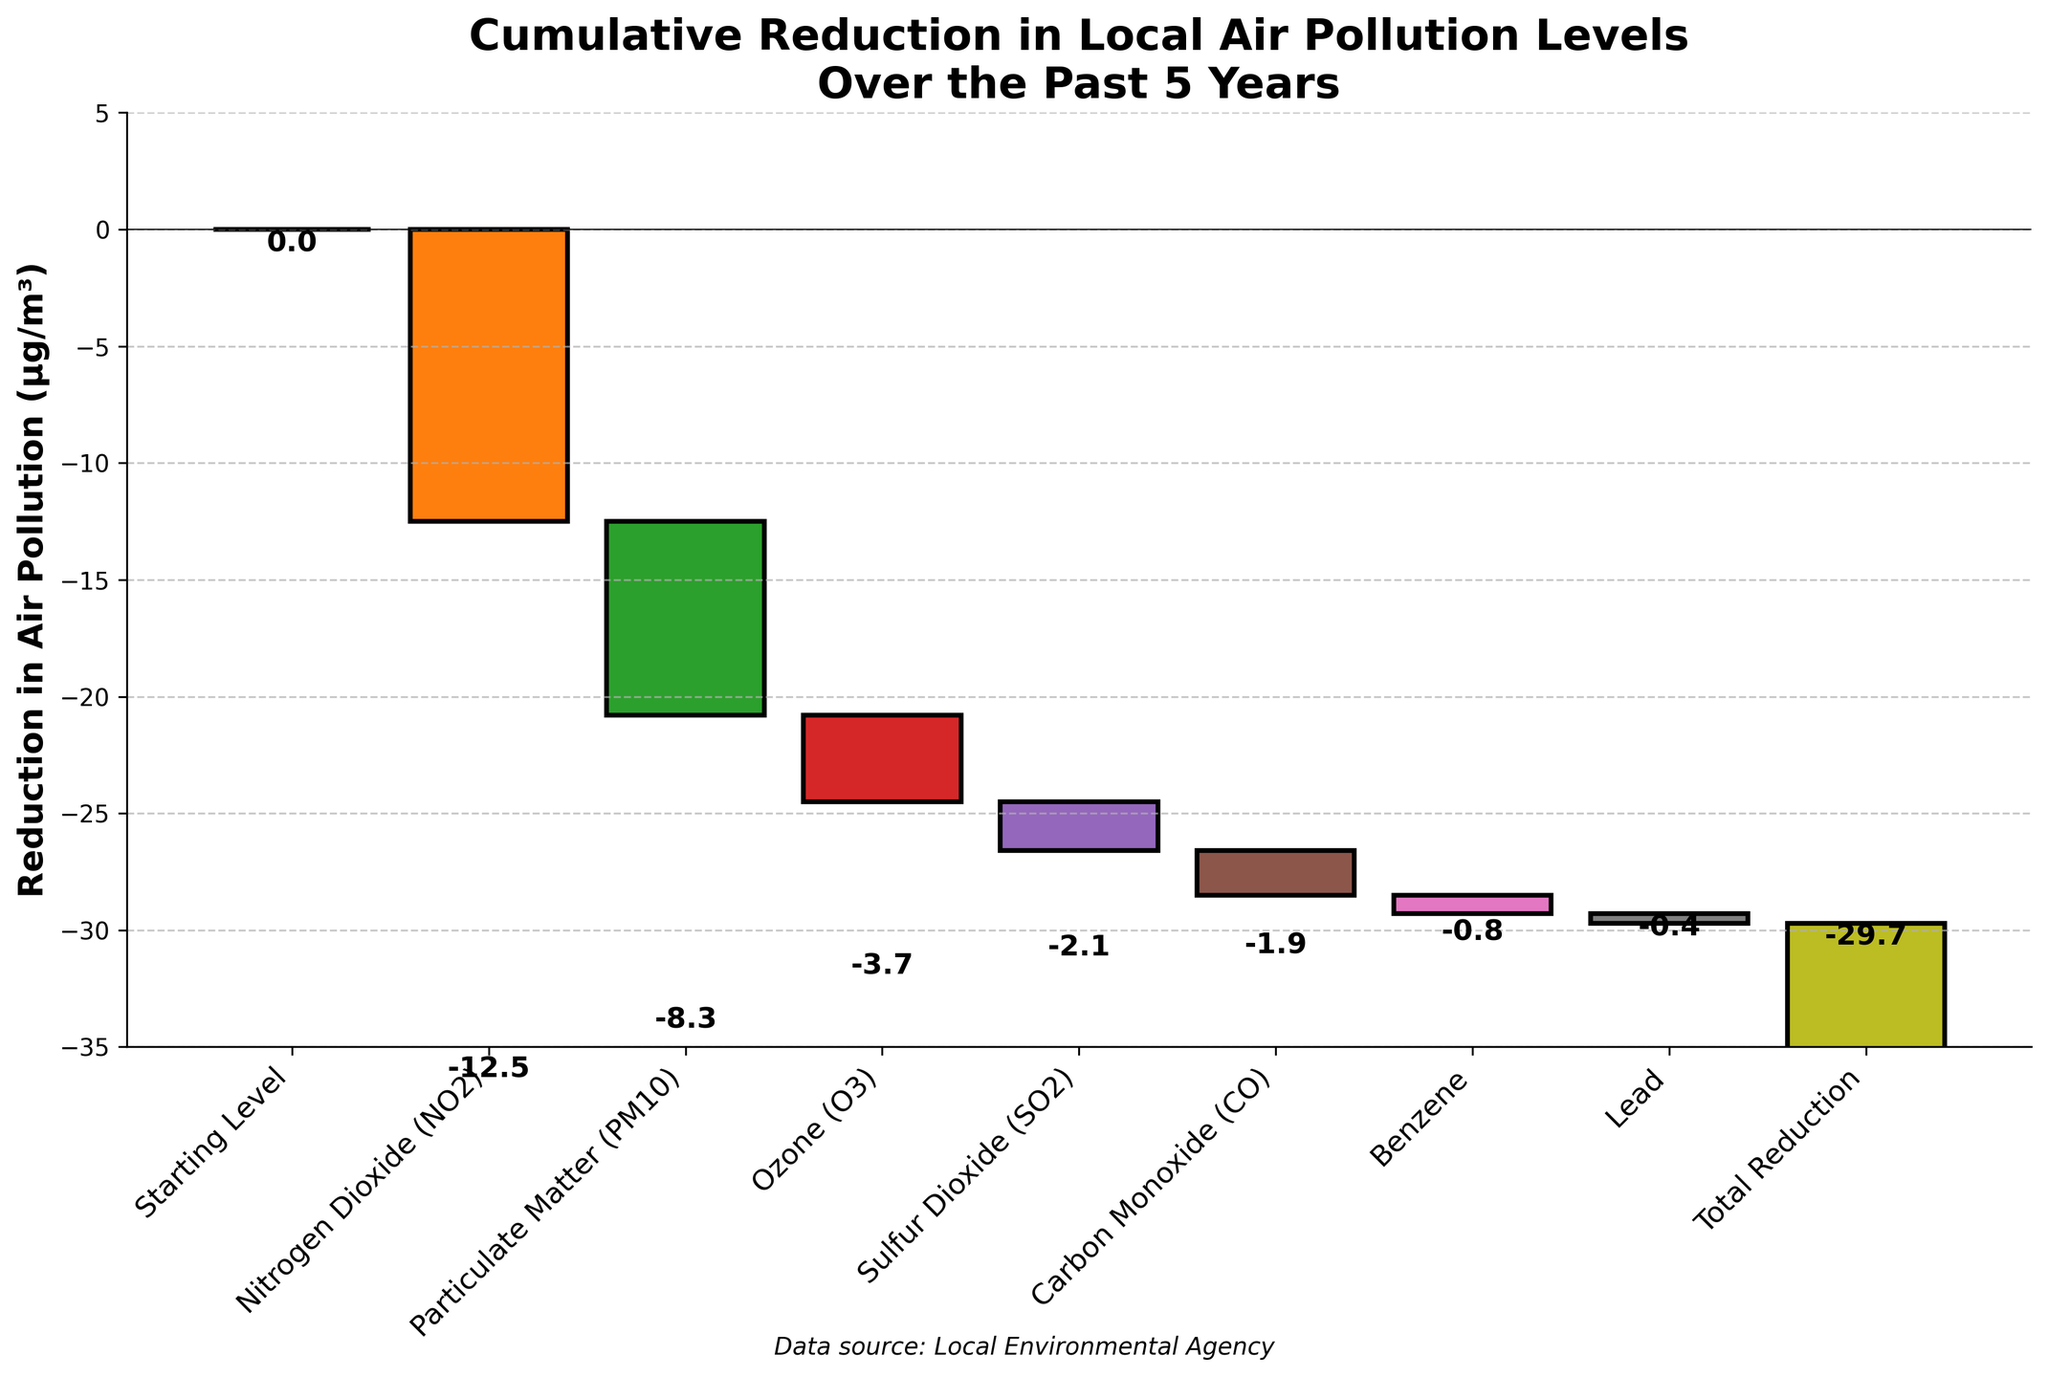What's the total reduction in local air pollution levels over the past 5 years? The chart's title states "Cumulative Reduction in Local Air Pollution Levels Over the Past 5 Years," and the bar labeled "Total Reduction" at the end shows a value of -29.7 µg/m³. So, the total reduction is -29.7 µg/m³.
Answer: -29.7 µg/m³ Which pollutant type had the largest reduction in air pollution? Looking at the bars in the chart, the Nitrogen Dioxide (NO2) bar has the largest negative value, indicating the largest reduction in air pollution levels.
Answer: Nitrogen Dioxide (NO2) Which pollutant shows the smallest reduction in air pollution levels? By comparing the bars, the Lead bar has the smallest negative value of -0.4 µg/m³.
Answer: Lead How much more reduction in air pollution was achieved by Nitrogen Dioxide (NO2) compared to Ozone (O3)? The reduction for NO2 is -12.5 µg/m³, and for O3, it is -3.7 µg/m³. The difference is -12.5 - (-3.7) = -12.5 + 3.7 = -8.8 µg/m³.
Answer: -8.8 µg/m³ What is the combined reduction for Particulate Matter (PM10) and Carbon Monoxide (CO)? The reduction for PM10 is -8.3 µg/m³ and for CO is -1.9 µg/m³. Adding them gives -8.3 + (-1.9) = -10.2 µg/m³.
Answer: -10.2 µg/m³ How many different pollutant types are shown in the chart? Counting all the bars except the "Starting Level" and "Total Reduction" bars, there are 7 different pollutant types.
Answer: 7 What is the difference in reduction between Particulate Matter (PM10) and Benzene? The reduction for PM10 is -8.3 µg/m³ and for Benzene is -0.8 µg/m³. The difference is -8.3 - (-0.8) = -8.3 + 0.8 = -7.5 µg/m³.
Answer: -7.5 µg/m³ Which pollutant type has the second largest reduction in air pollution? Based on the bars' lengths, Particulate Matter (PM10) has the second largest reduction with -8.3 µg/m³.
Answer: Particulate Matter (PM10) 